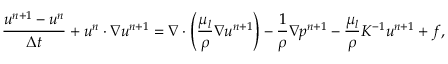Convert formula to latex. <formula><loc_0><loc_0><loc_500><loc_500>\frac { u ^ { n + 1 } - u ^ { n } } { \Delta t } + u ^ { n } \cdot \nabla u ^ { n + 1 } = \nabla \cdot \left ( \frac { \mu _ { l } } { \rho } \nabla u ^ { n + 1 } \right ) - \frac { 1 } { \rho } \nabla p ^ { n + 1 } - \frac { \mu _ { l } } { \rho } K ^ { - 1 } u ^ { n + 1 } + f ,</formula> 